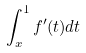<formula> <loc_0><loc_0><loc_500><loc_500>\int _ { x } ^ { 1 } f ^ { \prime } ( t ) d t</formula> 